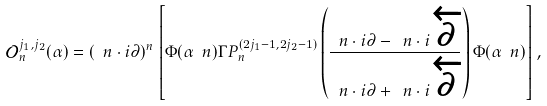<formula> <loc_0><loc_0><loc_500><loc_500>\mathcal { O } _ { n } ^ { j _ { 1 } , j _ { 2 } } ( \alpha ) = ( \ n \cdot i \partial ) ^ { n } \left [ \Phi ( \alpha \ n ) \Gamma P _ { n } ^ { ( 2 j _ { 1 } - 1 , 2 j _ { 2 } - 1 ) } \left ( \frac { \ n \cdot i \partial - \ n \cdot i \overleftarrow { \partial } } { \ n \cdot i \partial + \ n \cdot i \overleftarrow { \partial } } \right ) \Phi ( \alpha \ n ) \right ] ,</formula> 